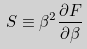<formula> <loc_0><loc_0><loc_500><loc_500>S \equiv \beta ^ { 2 } \frac { \partial F } { \partial \beta }</formula> 